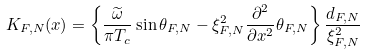Convert formula to latex. <formula><loc_0><loc_0><loc_500><loc_500>K _ { F , N } ( x ) = \left \{ \frac { \widetilde { \omega } } { \pi T _ { c } } \sin \theta _ { F , N } - \xi _ { F , N } ^ { 2 } \frac { \partial ^ { 2 } } { \partial x ^ { 2 } } \theta _ { F , N } \right \} \frac { d _ { F , N } } { \xi _ { F , N } ^ { 2 } }</formula> 